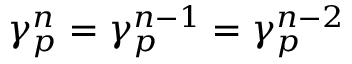<formula> <loc_0><loc_0><loc_500><loc_500>\gamma _ { p } ^ { n } = \gamma _ { p } ^ { n - 1 } = \gamma _ { p } ^ { n - 2 }</formula> 